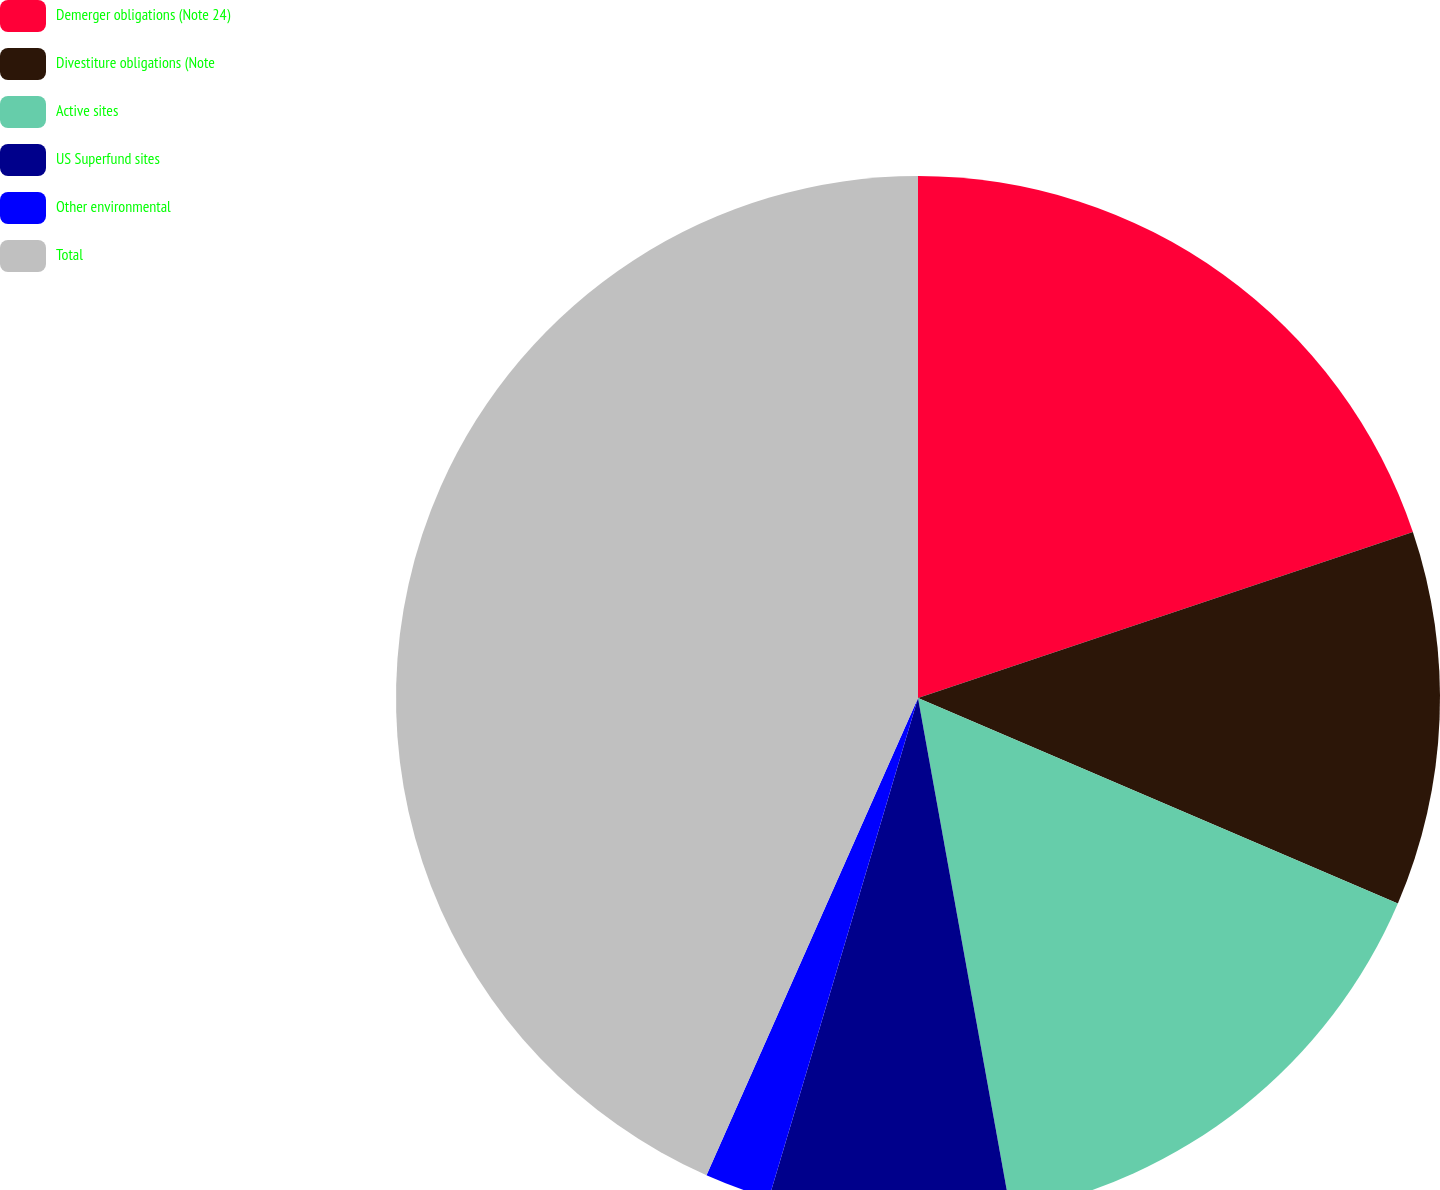Convert chart to OTSL. <chart><loc_0><loc_0><loc_500><loc_500><pie_chart><fcel>Demerger obligations (Note 24)<fcel>Divestiture obligations (Note<fcel>Active sites<fcel>US Superfund sites<fcel>Other environmental<fcel>Total<nl><fcel>19.85%<fcel>11.59%<fcel>15.72%<fcel>7.45%<fcel>2.03%<fcel>43.36%<nl></chart> 